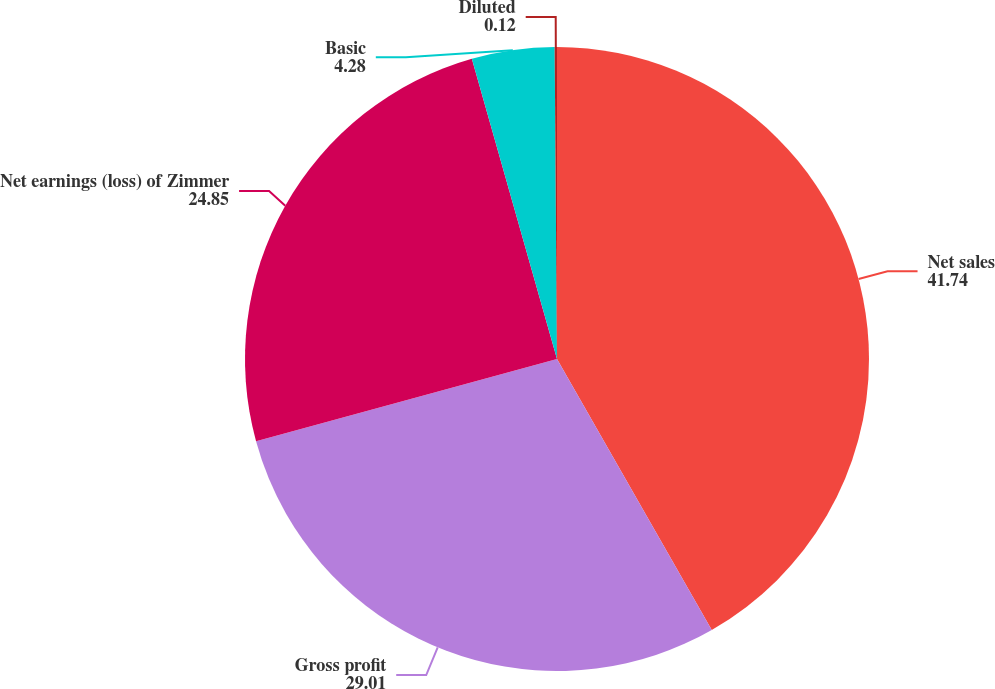Convert chart to OTSL. <chart><loc_0><loc_0><loc_500><loc_500><pie_chart><fcel>Net sales<fcel>Gross profit<fcel>Net earnings (loss) of Zimmer<fcel>Basic<fcel>Diluted<nl><fcel>41.74%<fcel>29.01%<fcel>24.85%<fcel>4.28%<fcel>0.12%<nl></chart> 